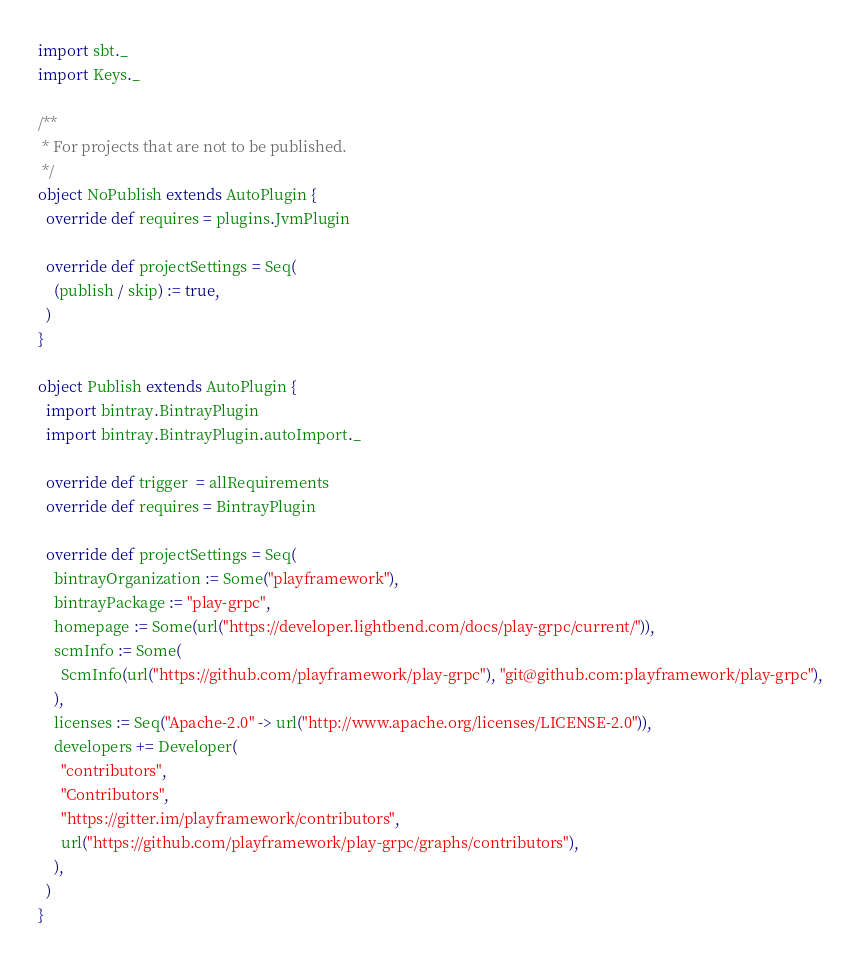Convert code to text. <code><loc_0><loc_0><loc_500><loc_500><_Scala_>
import sbt._
import Keys._

/**
 * For projects that are not to be published.
 */
object NoPublish extends AutoPlugin {
  override def requires = plugins.JvmPlugin

  override def projectSettings = Seq(
    (publish / skip) := true,
  )
}

object Publish extends AutoPlugin {
  import bintray.BintrayPlugin
  import bintray.BintrayPlugin.autoImport._

  override def trigger  = allRequirements
  override def requires = BintrayPlugin

  override def projectSettings = Seq(
    bintrayOrganization := Some("playframework"),
    bintrayPackage := "play-grpc",
    homepage := Some(url("https://developer.lightbend.com/docs/play-grpc/current/")),
    scmInfo := Some(
      ScmInfo(url("https://github.com/playframework/play-grpc"), "git@github.com:playframework/play-grpc"),
    ),
    licenses := Seq("Apache-2.0" -> url("http://www.apache.org/licenses/LICENSE-2.0")),
    developers += Developer(
      "contributors",
      "Contributors",
      "https://gitter.im/playframework/contributors",
      url("https://github.com/playframework/play-grpc/graphs/contributors"),
    ),
  )
}
</code> 